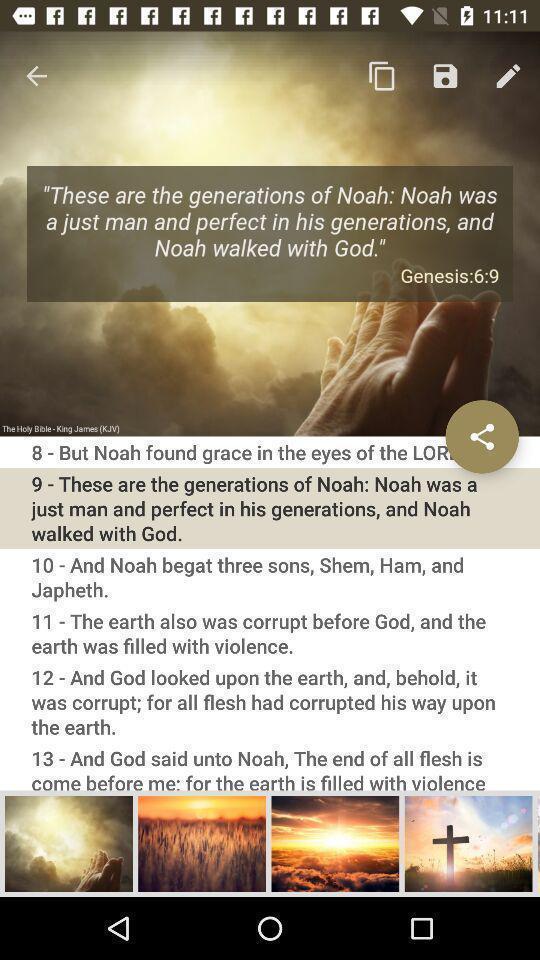Describe the key features of this screenshot. Page displaying information with different options. 